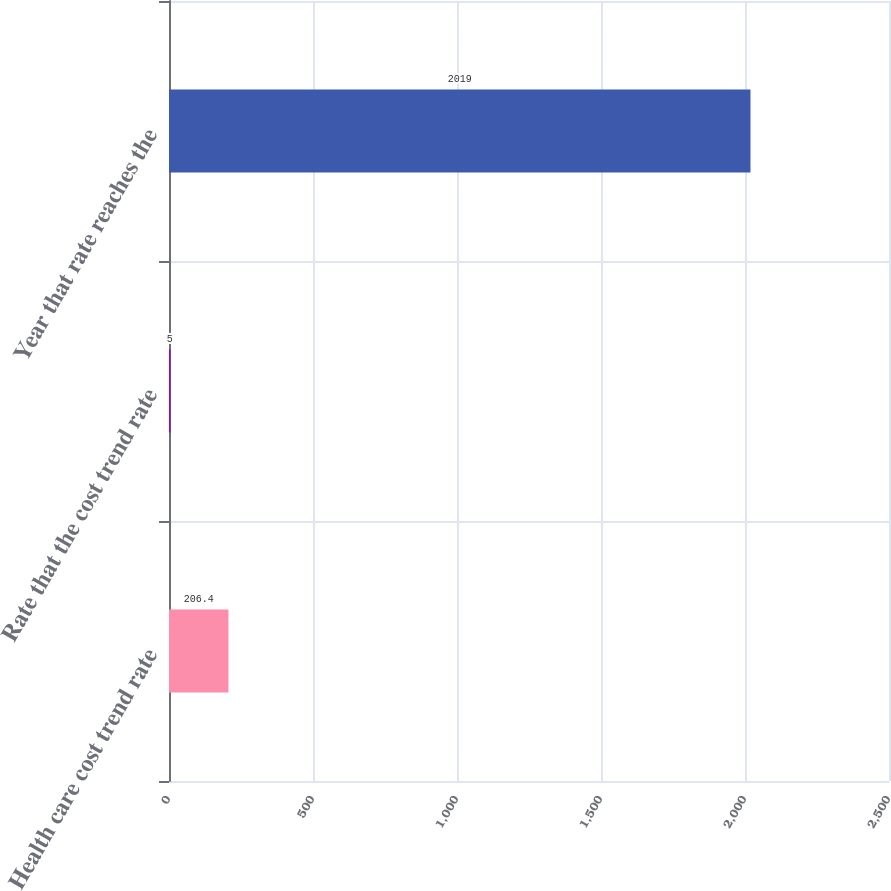Convert chart to OTSL. <chart><loc_0><loc_0><loc_500><loc_500><bar_chart><fcel>Health care cost trend rate<fcel>Rate that the cost trend rate<fcel>Year that rate reaches the<nl><fcel>206.4<fcel>5<fcel>2019<nl></chart> 